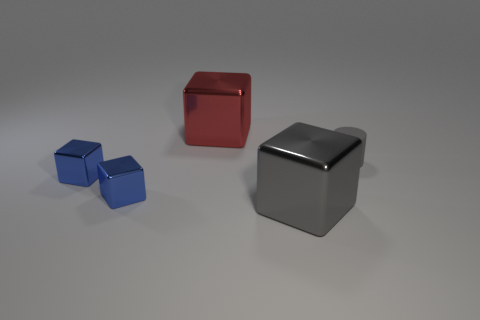What size is the shiny thing that is the same color as the tiny cylinder?
Offer a terse response. Large. How many tiny objects are either red metal objects or brown metallic spheres?
Provide a short and direct response. 0. Is there any other thing of the same color as the matte cylinder?
Make the answer very short. Yes. There is a object that is behind the tiny thing right of the metal block to the right of the large red metallic thing; what is it made of?
Your answer should be compact. Metal. What number of matte objects are either tiny blue objects or cubes?
Give a very brief answer. 0. How many blue things are shiny things or small balls?
Make the answer very short. 2. Do the large shiny thing that is in front of the red metallic object and the small rubber thing have the same color?
Make the answer very short. Yes. Is the cylinder made of the same material as the big gray thing?
Offer a terse response. No. Are there an equal number of tiny blue blocks in front of the red shiny thing and tiny blue metal cubes that are to the right of the big gray block?
Your response must be concise. No. What material is the gray object that is the same shape as the big red thing?
Provide a short and direct response. Metal. 